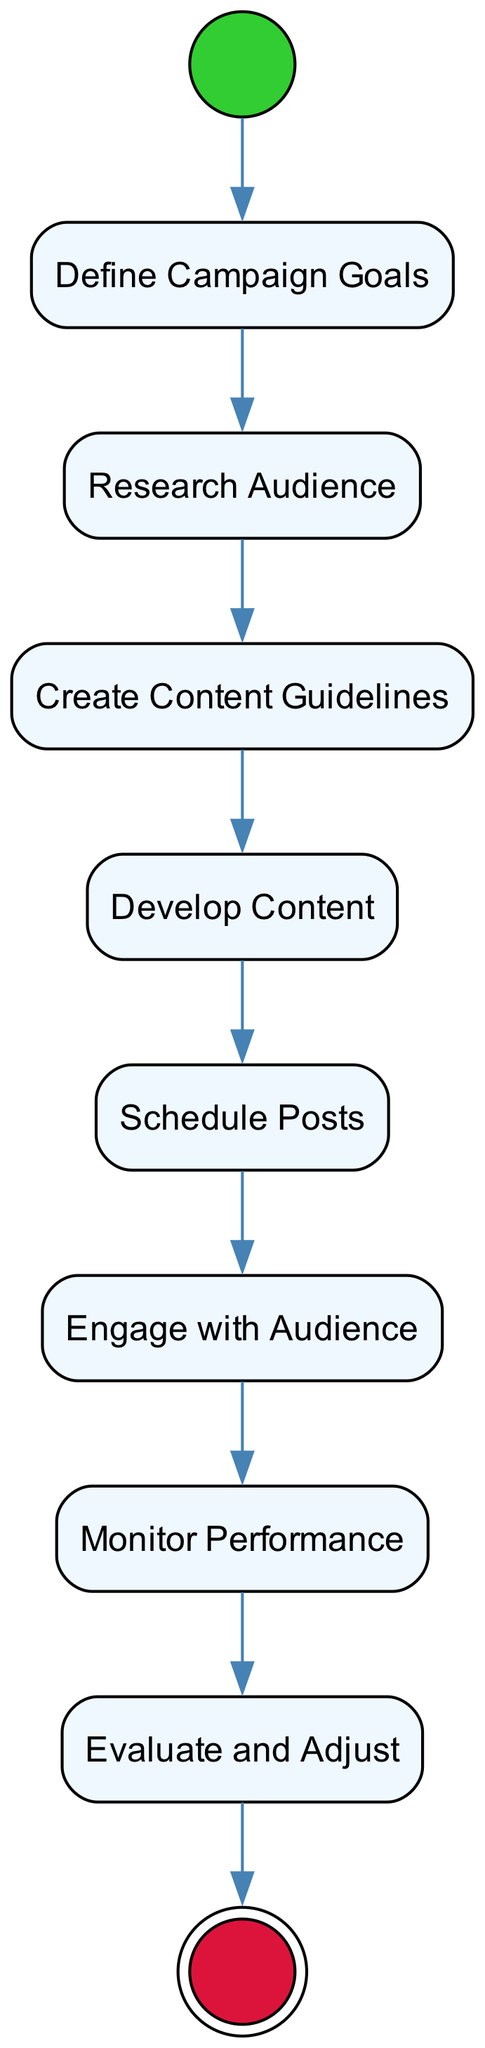What is the first activity in the campaign? The first activity in the diagram is the "Define Campaign Goals." This is located immediately after the initial node labeled "Start Campaign."
Answer: Define Campaign Goals How many activities are there in the campaign? Counting all the activity nodes from "Define Campaign Goals" to "Evaluate and Adjust," there are a total of 8 activities represented in the diagram.
Answer: 8 What is the last step before ending the campaign? The last step before the final node "End Campaign" is the "Evaluate and Adjust" activity, which is the final activity in the workflow.
Answer: Evaluate and Adjust Which activity involves interaction with followers? The activity that focuses on interaction with followers is "Engage with Audience." It emphasizes building a community by responding to comments and interacting with the audience.
Answer: Engage with Audience What comes after developing content? After "Develop Content," the next activity is "Schedule Posts," indicating a sequential flow from content creation to scheduling.
Answer: Schedule Posts What is the main goal of the campaign? The main goal of the campaign is outlined in the "Define Campaign Goals" activity, which specifies establishing ethical standards and objectives for the art campaign.
Answer: Ethical standards and objectives How does the campaign ensure its effectiveness? The campaign ensures its effectiveness by implementing the "Monitor Performance" activity, which tracks analytics to assess the campaign's impact and reach. This connects to the need for continuous evaluation and improvement.
Answer: Monitor Performance Which activity should be completed before the audience is engaged? Before engaging with the audience, the "Schedule Posts" activity should be completed to ensure the campaign content is properly released on social media.
Answer: Schedule Posts 